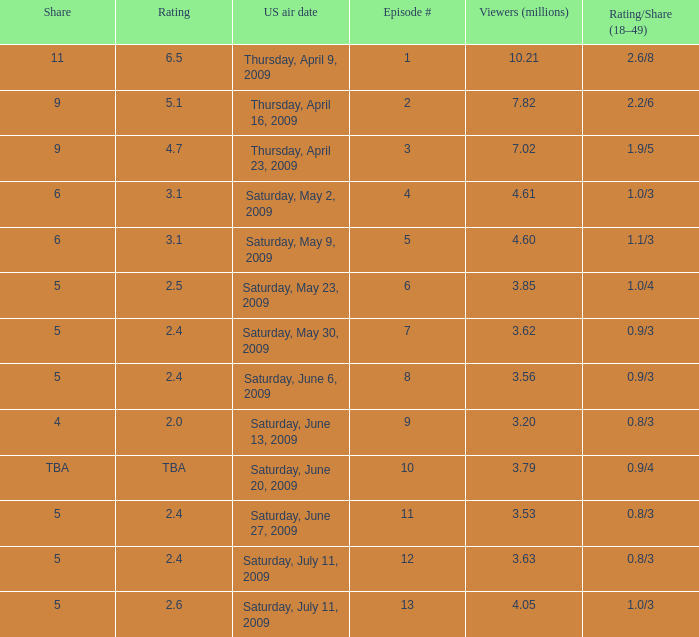What is the lowest numbered episode that had a rating/share of 0.9/4 and more than 3.79 million viewers? None. 